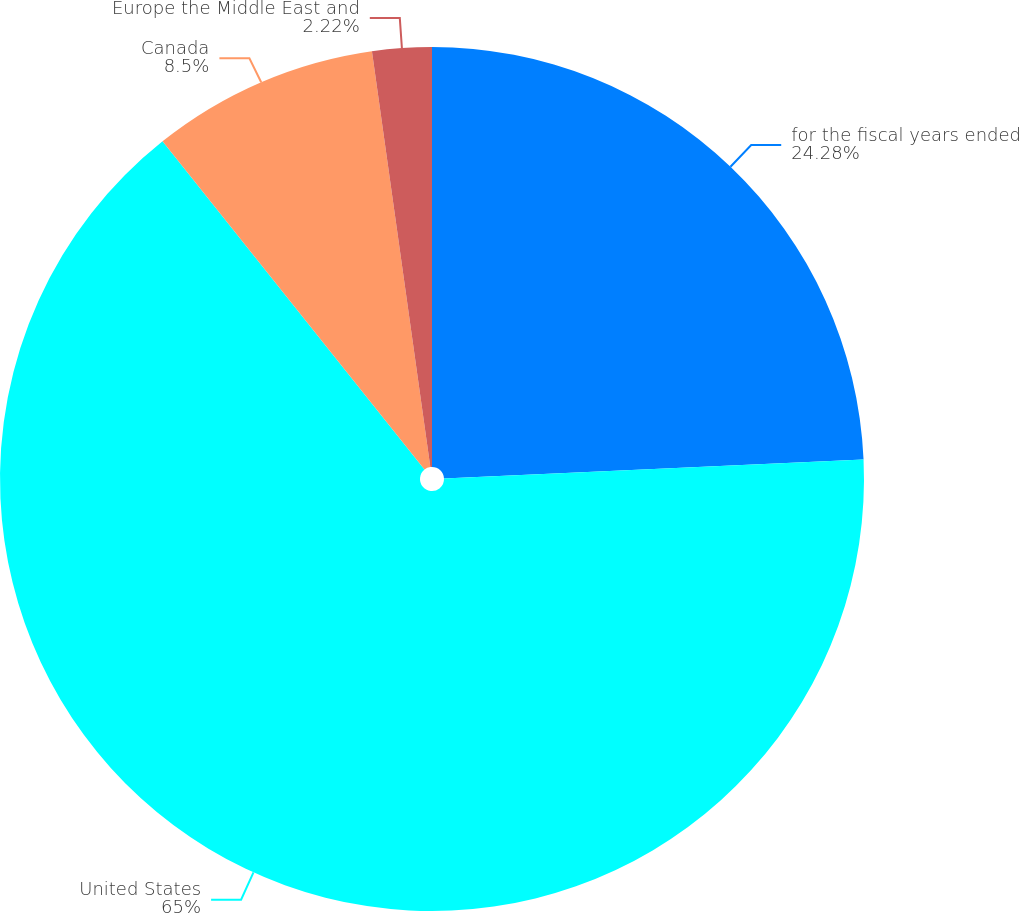<chart> <loc_0><loc_0><loc_500><loc_500><pie_chart><fcel>for the fiscal years ended<fcel>United States<fcel>Canada<fcel>Europe the Middle East and<nl><fcel>24.28%<fcel>65.0%<fcel>8.5%<fcel>2.22%<nl></chart> 